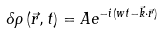<formula> <loc_0><loc_0><loc_500><loc_500>\delta \rho \left ( \vec { r } , t \right ) = A e ^ { - i ( w t - \vec { k } \cdot \vec { r } ) }</formula> 